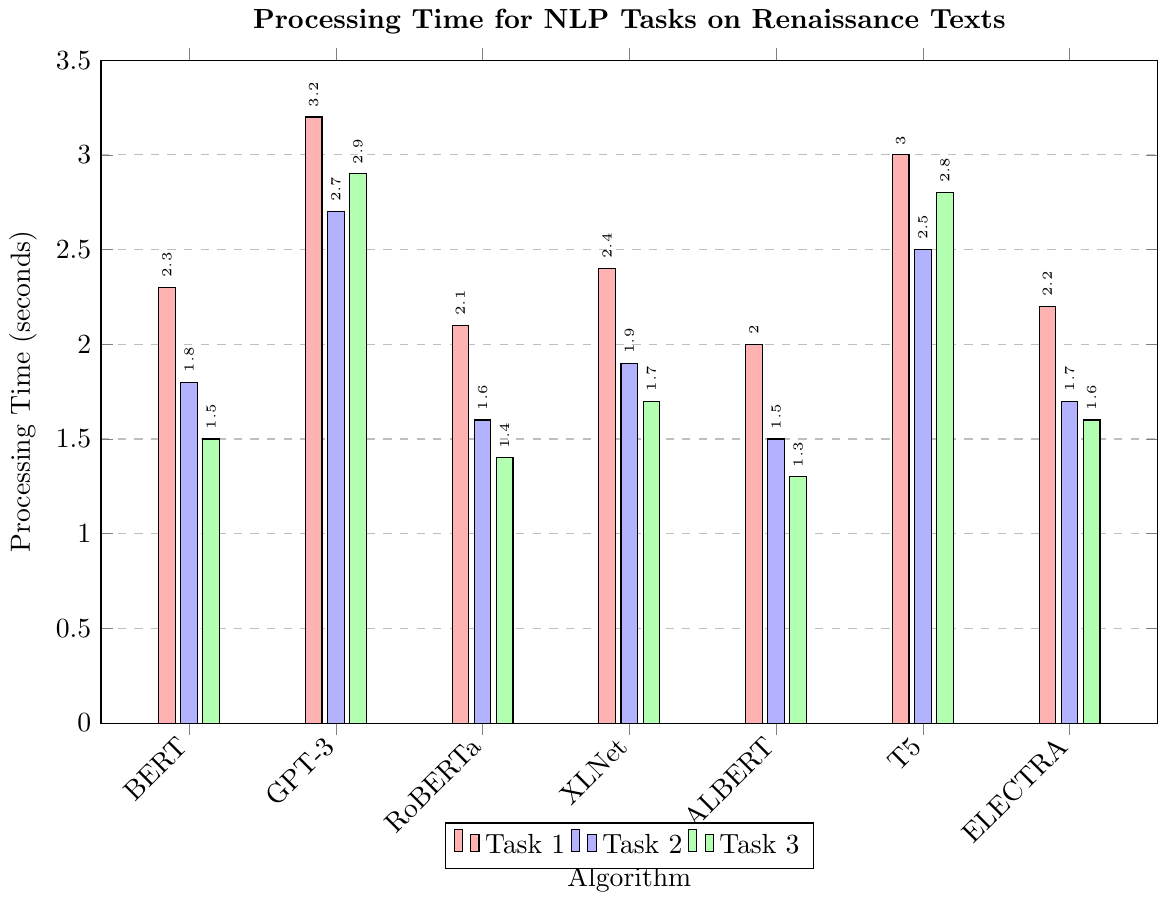Which algorithm has the highest processing time for Text Generation? The bar chart shows the processing time for each algorithm. For Text Generation, the highest bar corresponds to GPT-3 with a processing time of 3.2 seconds.
Answer: GPT-3 Which task has the lowest processing time using BERT? Observing the BERT section of the bar chart, the lowest bar is for Part-of-Speech Tagging with a processing time of 1.5 seconds.
Answer: Part-of-Speech Tagging Compare the processing time for Named Entity Recognition between ALBERT and RoBERTa. Which one is faster? Check the heights of the bars for Named Entity Recognition corresponding to ALBERT and RoBERTa. ALBERT has a processing time of 2.0 seconds, whereas RoBERTa has a processing time of 2.1 seconds. Therefore, ALBERT is faster.
Answer: ALBERT What's the total processing time of Sentiment Analysis using all algorithms? Add up the processing times for Sentiment Analysis across all algorithms: 1.8 (BERT) + 2.7 (GPT-3) + 1.6 (RoBERTa) + 1.9 (XLNet) + 1.5 (ALBERT) + 1.7 (ELECTRA) = 11.2 seconds
Answer: 11.2 seconds Which algorithm has the largest processing time difference between Named Entity Recognition and Part-of-Speech Tagging? Calculate the differences for each algorithm:
BERT: 2.3 - 1.5 = 0.8,
RoBERTa: 2.1 - 1.4 = 0.7,
XLNet: 2.4 - 1.7 = 0.7,
ALBERT: 2.0 - 1.3 = 0.7,
ELECTRA: 2.2 - 1.6 = 0.6.
BERT has the largest difference of 0.8 seconds.
Answer: BERT For summarization tasks, does T5 perform faster than GPT-3? Compare the bars for the summarization task for T5 and GPT-3. T5 has a processing time of 2.8 seconds, while GPT-3 has a processing time of 2.9 seconds. Therefore, T5 is faster.
Answer: Yes What is the average processing time for Part-of-Speech Tagging across all algorithms? Calculate the average by summing the processing times and dividing by the number of algorithms: (1.5 + 1.4 + 1.7 + 1.3 + 1.6) / 5 = 7.5 / 5 = 1.5 seconds.
Answer: 1.5 seconds Among RoBERTa, XLNet, and ELECTRA, which algorithm is the fastest for Sentiment Analysis? Compare the bars for Sentiment Analysis for these algorithms. RoBERTa has a processing time of 1.6 seconds, XLNet has 1.9 seconds, and ELECTRA has 1.7 seconds. RoBERTa is the fastest.
Answer: RoBERTa What’s the median processing time for Named Entity Recognition considering all the algorithms? List the processing times and find the middle value: 2.0 (ALBERT), 2.1 (RoBERTa), 2.2 (ELECTRA), 2.3 (BERT), 2.4 (XLNet). The median value is 2.2 seconds.
Answer: 2.2 seconds 